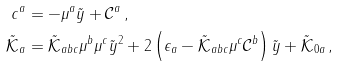Convert formula to latex. <formula><loc_0><loc_0><loc_500><loc_500>c ^ { a } & = - \mu ^ { a } \tilde { y } + \mathcal { C } ^ { a } \, , \\ \tilde { \mathcal { K } } _ { a } & = \tilde { \mathcal { K } } _ { a b c } \mu ^ { b } \mu ^ { c } \tilde { y } ^ { 2 } + 2 \left ( \epsilon _ { a } - \tilde { \mathcal { K } } _ { a b c } \mu ^ { c } \mathcal { C } ^ { b } \right ) \tilde { y } + \tilde { \mathcal { K } } _ { 0 a } \, ,</formula> 